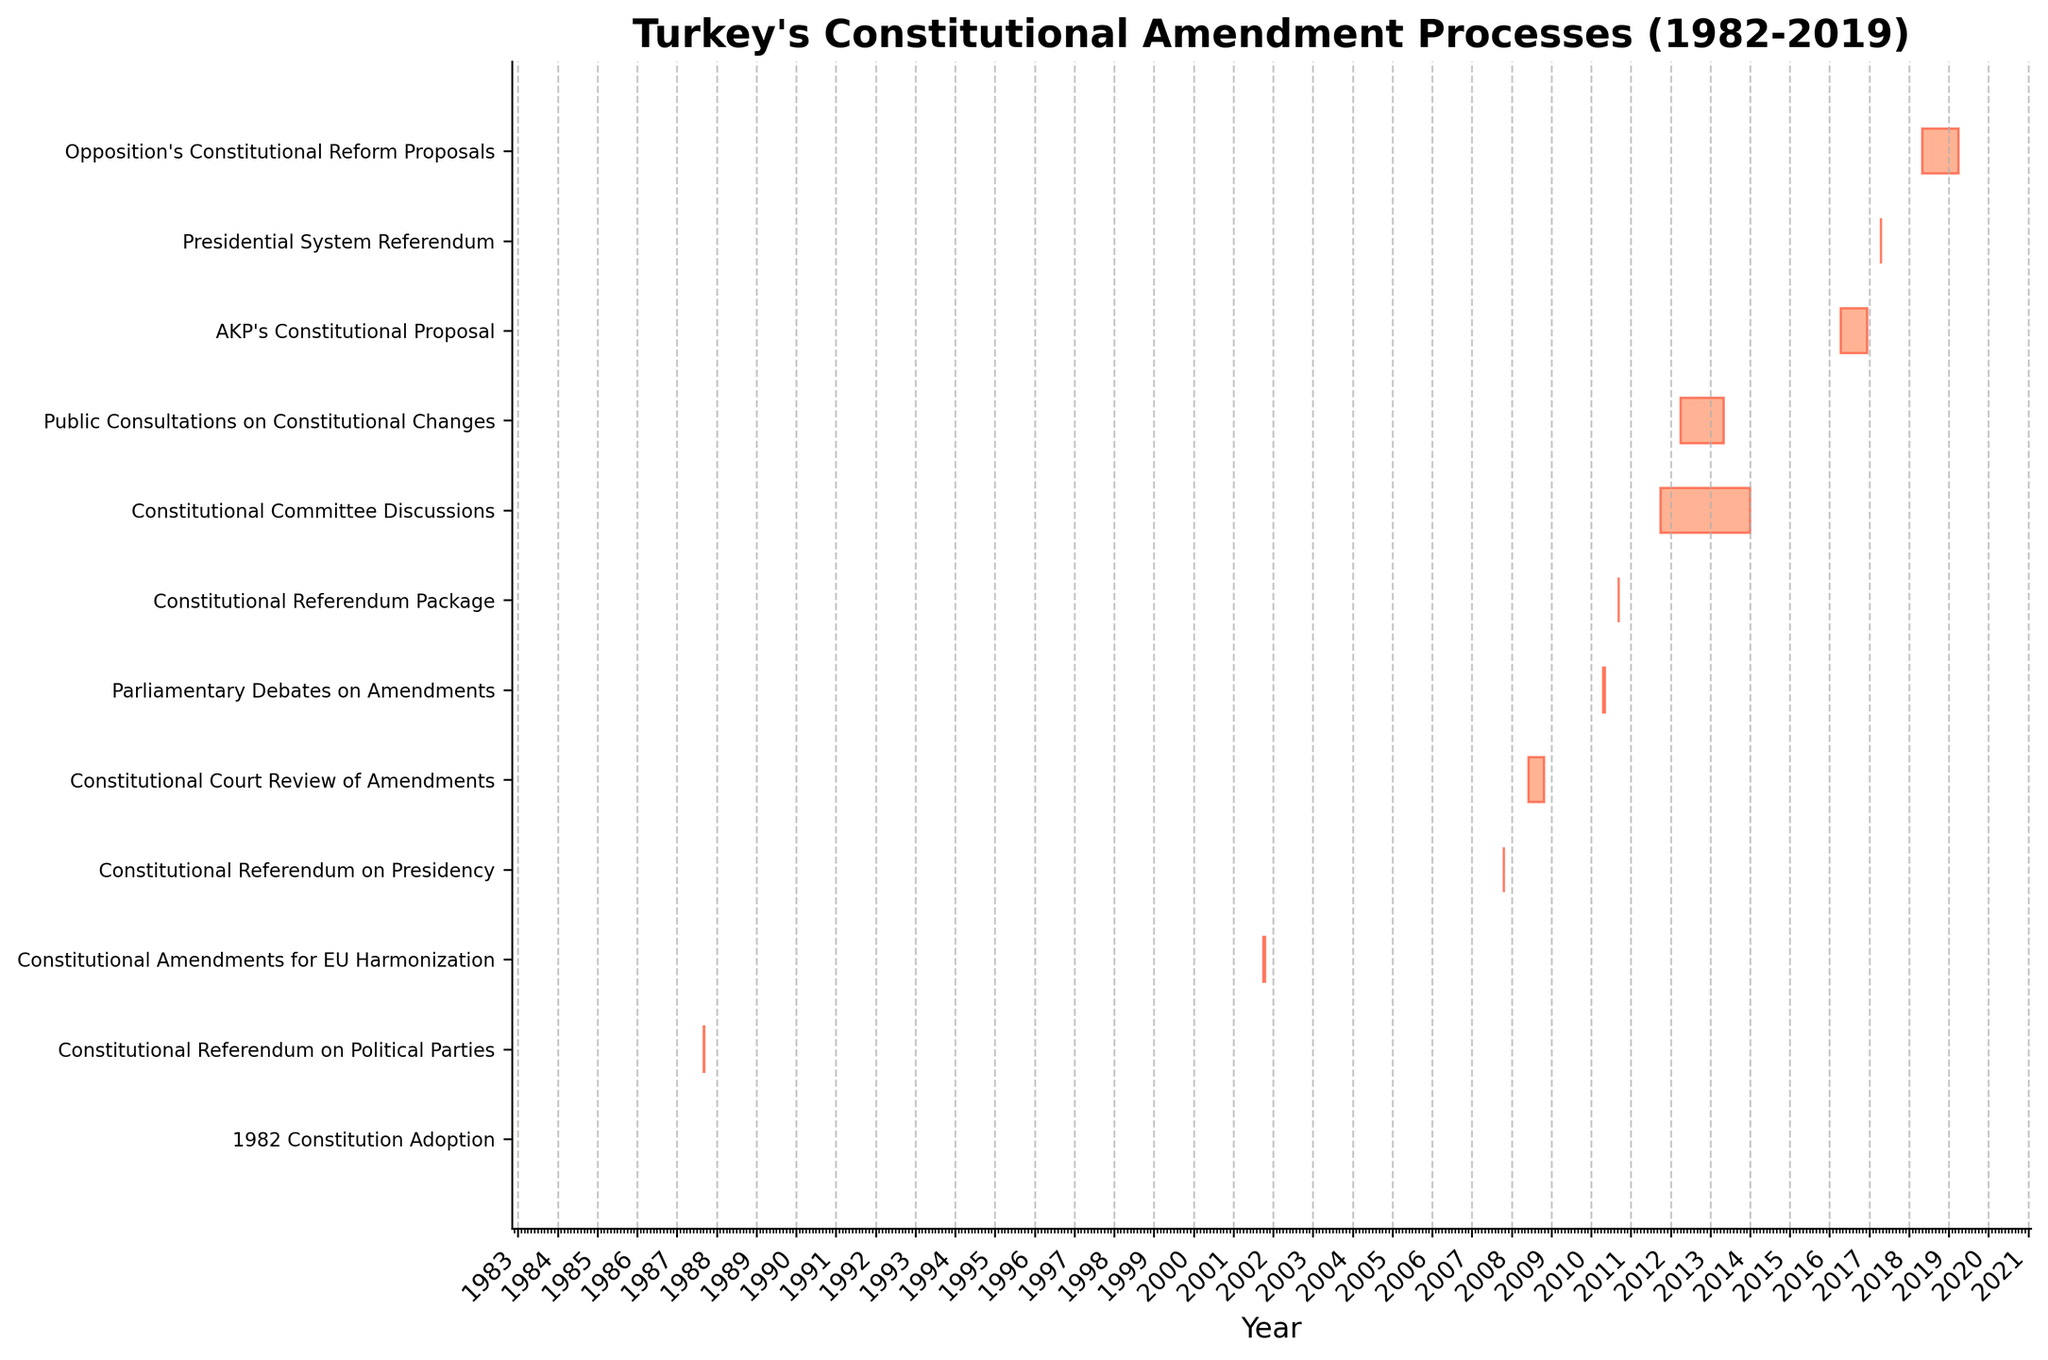What's the title of the Gantt chart? The title can be found at the top of the Gantt chart. It usually provides an overview of the content of the chart.
Answer: Turkey's Constitutional Amendment Processes (1982-2019) How many constitutional amendment processes are displayed in the Gantt chart? Count the number of bars or tasks listed in the Gantt chart. Each bar represents a different constitutional amendment process.
Answer: 12 Which task lasted the longest, and how long did it last? Identify the bars for each task and find the one that extends furthest along the timeline. Calculate the number of days between its start and end dates.
Answer: Constitutional Committee Discussions; 2 years and 3 months In what year was the 1982 Constitution adopted? Look for the task labeled '1982 Constitution Adoption' and identify its corresponding year.
Answer: 1982 How many constitutional amendment processes occurred specifically between 2001 and 2010? Identify bars (tasks) that fall within the years 2001 to 2010. Include those that start and end within this period.
Answer: 3 Compare the durations of the 'Constitutional Committee Discussions' and 'AKP's Constitutional Proposal'. Which one was longer and by how many days? Identify the start and end dates for both tasks, calculate their durations in days, and then compare these durations.
Answer: Constitutional Committee Discussions was longer by 557 days Which task was conducted the earliest after the 1982 Constitution Adoption, and in which year was it conducted? Find the task with the earliest start date following the 1982 Constitution Adoption.
Answer: Constitutional Referendum on Political Parties; 1987 How many tasks involved a referendum? Identify tasks by their labels that mention 'Referendum' and count them.
Answer: 4 During which period did the 'Public Consultations on Constitutional Changes' take place? Look for the task labeled 'Public Consultations on Constitutional Changes' and note its start and end dates.
Answer: April 2012 to April 2013 What is the gap between the 'Presidential System Referendum' and the 'Opposition's Constitutional Reform Proposals'? Identify the end date of the 'Presidential System Referendum' and the start date of the 'Opposition's Constitutional Reform Proposals', then calculate the duration in between.
Answer: 1 year 